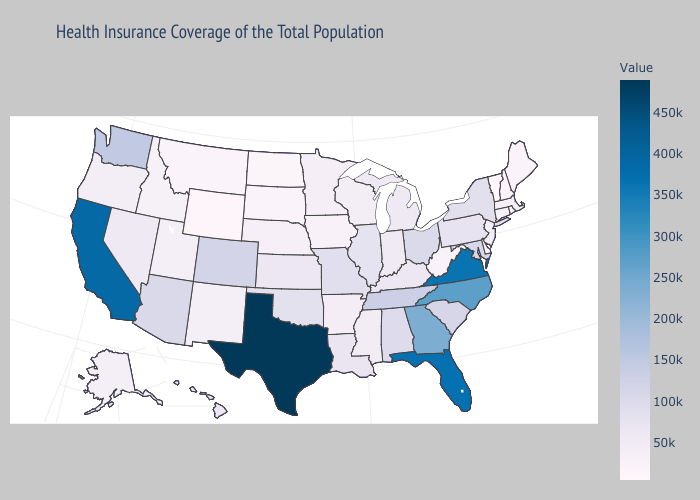Which states have the highest value in the USA?
Keep it brief. Texas. Does Colorado have a higher value than Georgia?
Concise answer only. No. Which states have the highest value in the USA?
Answer briefly. Texas. Does Montana have the lowest value in the West?
Short answer required. No. Does Delaware have the lowest value in the South?
Keep it brief. Yes. 